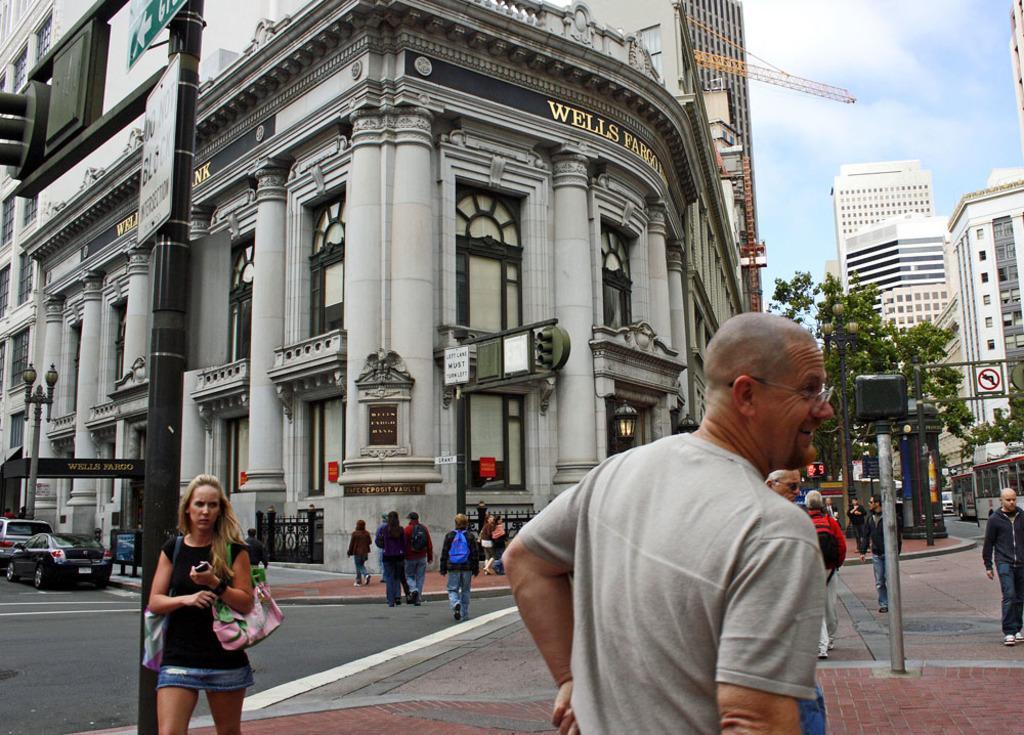How would you summarize this image in a sentence or two? There are people and we can see boards, lights and traffic signals on poles and vehicles on the road. In the background we can see buildings, crane, trees and sky. 